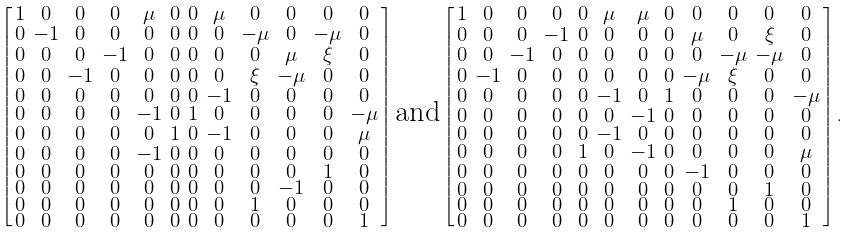Convert formula to latex. <formula><loc_0><loc_0><loc_500><loc_500>\left [ \begin{smallmatrix} 1 & 0 & 0 & 0 & \mu & 0 & 0 & \mu & 0 & 0 & 0 & 0 \\ 0 & - 1 & 0 & 0 & 0 & 0 & 0 & 0 & - \mu & 0 & - \mu & 0 \\ 0 & 0 & 0 & - 1 & 0 & 0 & 0 & 0 & 0 & \mu & \xi & 0 \\ 0 & 0 & - 1 & 0 & 0 & 0 & 0 & 0 & \xi & - \mu & 0 & 0 \\ 0 & 0 & 0 & 0 & 0 & 0 & 0 & - 1 & 0 & 0 & 0 & 0 \\ 0 & 0 & 0 & 0 & - 1 & 0 & 1 & 0 & 0 & 0 & 0 & - \mu \\ 0 & 0 & 0 & 0 & 0 & 1 & 0 & - 1 & 0 & 0 & 0 & \mu \\ 0 & 0 & 0 & 0 & - 1 & 0 & 0 & 0 & 0 & 0 & 0 & 0 \\ 0 & 0 & 0 & 0 & 0 & 0 & 0 & 0 & 0 & 0 & 1 & 0 \\ 0 & 0 & 0 & 0 & 0 & 0 & 0 & 0 & 0 & - 1 & 0 & 0 \\ 0 & 0 & 0 & 0 & 0 & 0 & 0 & 0 & 1 & 0 & 0 & 0 \\ 0 & 0 & 0 & 0 & 0 & 0 & 0 & 0 & 0 & 0 & 0 & 1 \end{smallmatrix} \right ] \text {and} \left [ \begin{smallmatrix} 1 & 0 & 0 & 0 & 0 & \mu & \mu & 0 & 0 & 0 & 0 & 0 \\ 0 & 0 & 0 & - 1 & 0 & 0 & 0 & 0 & \mu & 0 & \xi & 0 \\ 0 & 0 & - 1 & 0 & 0 & 0 & 0 & 0 & 0 & - \mu & - \mu & 0 \\ 0 & - 1 & 0 & 0 & 0 & 0 & 0 & 0 & - \mu & \xi & 0 & 0 \\ 0 & 0 & 0 & 0 & 0 & - 1 & 0 & 1 & 0 & 0 & 0 & - \mu \\ 0 & 0 & 0 & 0 & 0 & 0 & - 1 & 0 & 0 & 0 & 0 & 0 \\ 0 & 0 & 0 & 0 & 0 & - 1 & 0 & 0 & 0 & 0 & 0 & 0 \\ 0 & 0 & 0 & 0 & 1 & 0 & - 1 & 0 & 0 & 0 & 0 & \mu \\ 0 & 0 & 0 & 0 & 0 & 0 & 0 & 0 & - 1 & 0 & 0 & 0 \\ 0 & 0 & 0 & 0 & 0 & 0 & 0 & 0 & 0 & 0 & 1 & 0 \\ 0 & 0 & 0 & 0 & 0 & 0 & 0 & 0 & 0 & 1 & 0 & 0 \\ 0 & 0 & 0 & 0 & 0 & 0 & 0 & 0 & 0 & 0 & 0 & 1 \end{smallmatrix} \right ] .</formula> 